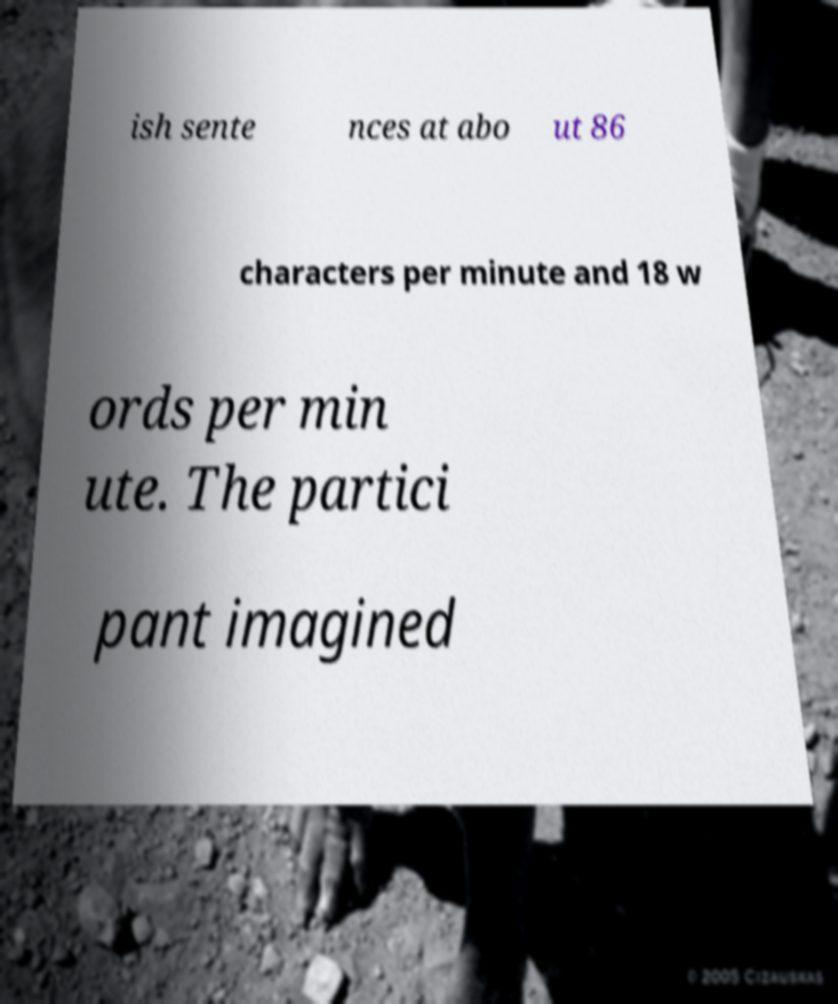For documentation purposes, I need the text within this image transcribed. Could you provide that? ish sente nces at abo ut 86 characters per minute and 18 w ords per min ute. The partici pant imagined 